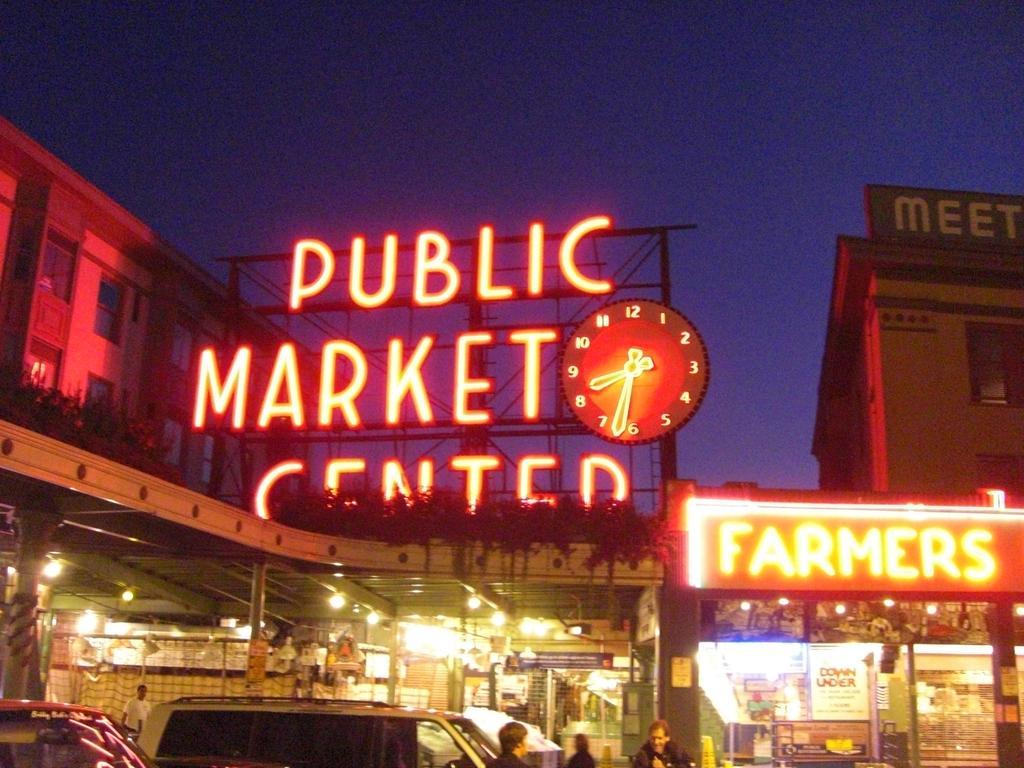Could you give a brief overview of what you see in this image? In this image we can see buildings, shops, there are boards with some text on it, there is a stand, there are a few people, vehicles, lights, also we can see the sky. 